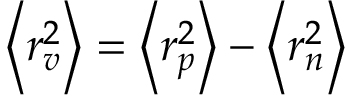Convert formula to latex. <formula><loc_0><loc_0><loc_500><loc_500>\left < r _ { v } ^ { 2 } \right > = \left < r _ { p } ^ { 2 } \right > - \left < r _ { n } ^ { 2 } \right ></formula> 